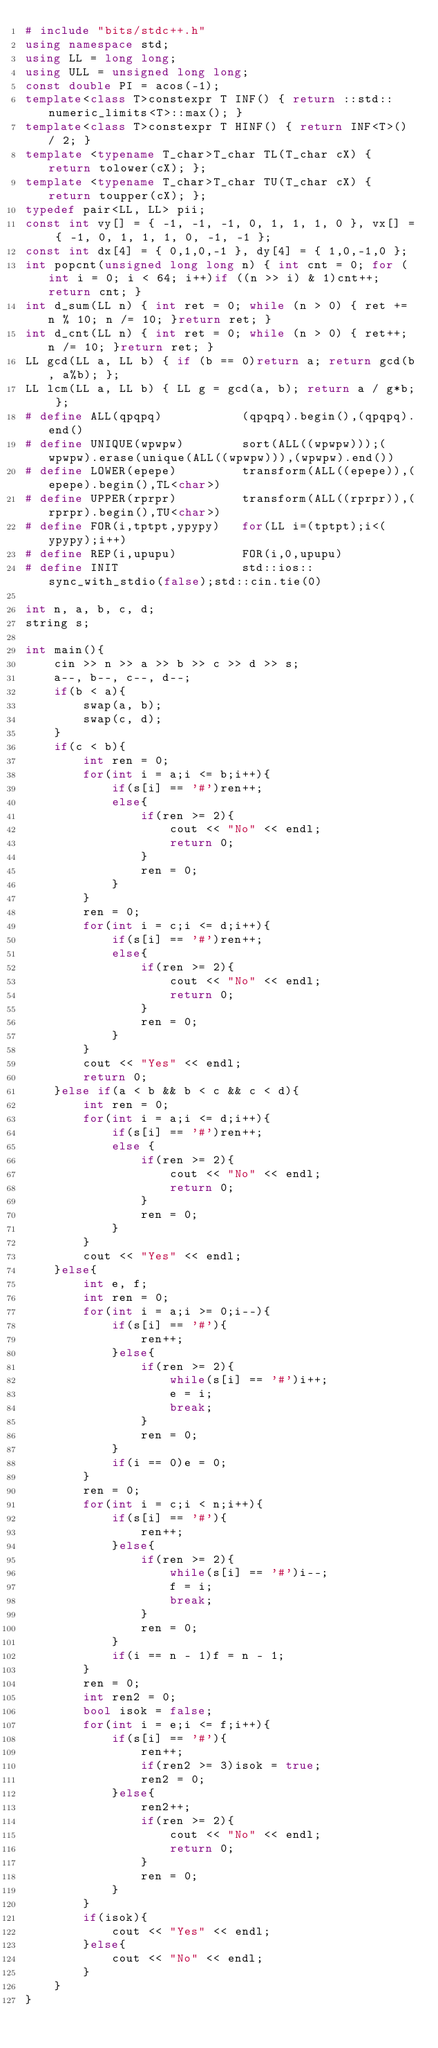<code> <loc_0><loc_0><loc_500><loc_500><_C++_># include "bits/stdc++.h"
using namespace std;
using LL = long long;
using ULL = unsigned long long;
const double PI = acos(-1);
template<class T>constexpr T INF() { return ::std::numeric_limits<T>::max(); }
template<class T>constexpr T HINF() { return INF<T>() / 2; }
template <typename T_char>T_char TL(T_char cX) { return tolower(cX); };
template <typename T_char>T_char TU(T_char cX) { return toupper(cX); };
typedef pair<LL, LL> pii;
const int vy[] = { -1, -1, -1, 0, 1, 1, 1, 0 }, vx[] = { -1, 0, 1, 1, 1, 0, -1, -1 };
const int dx[4] = { 0,1,0,-1 }, dy[4] = { 1,0,-1,0 };
int popcnt(unsigned long long n) { int cnt = 0; for (int i = 0; i < 64; i++)if ((n >> i) & 1)cnt++; return cnt; }
int d_sum(LL n) { int ret = 0; while (n > 0) { ret += n % 10; n /= 10; }return ret; }
int d_cnt(LL n) { int ret = 0; while (n > 0) { ret++; n /= 10; }return ret; }
LL gcd(LL a, LL b) { if (b == 0)return a; return gcd(b, a%b); };
LL lcm(LL a, LL b) { LL g = gcd(a, b); return a / g*b; };
# define ALL(qpqpq)           (qpqpq).begin(),(qpqpq).end()
# define UNIQUE(wpwpw)        sort(ALL((wpwpw)));(wpwpw).erase(unique(ALL((wpwpw))),(wpwpw).end())
# define LOWER(epepe)         transform(ALL((epepe)),(epepe).begin(),TL<char>)
# define UPPER(rprpr)         transform(ALL((rprpr)),(rprpr).begin(),TU<char>)
# define FOR(i,tptpt,ypypy)   for(LL i=(tptpt);i<(ypypy);i++)
# define REP(i,upupu)         FOR(i,0,upupu)
# define INIT                 std::ios::sync_with_stdio(false);std::cin.tie(0)

int n, a, b, c, d;
string s;

int main(){
    cin >> n >> a >> b >> c >> d >> s;
    a--, b--, c--, d--;
    if(b < a){
        swap(a, b);
        swap(c, d);
    }
    if(c < b){
        int ren = 0;
        for(int i = a;i <= b;i++){
            if(s[i] == '#')ren++;
            else{
                if(ren >= 2){
                    cout << "No" << endl;
                    return 0;
                }
                ren = 0;
            }
        }
        ren = 0;
        for(int i = c;i <= d;i++){
            if(s[i] == '#')ren++;
            else{
                if(ren >= 2){
                    cout << "No" << endl;
                    return 0;
                }
                ren = 0;
            }
        }
        cout << "Yes" << endl;
        return 0;
    }else if(a < b && b < c && c < d){
        int ren = 0;
        for(int i = a;i <= d;i++){
            if(s[i] == '#')ren++;
            else {
                if(ren >= 2){
                    cout << "No" << endl;
                    return 0;
                }
                ren = 0;
            }
        }
        cout << "Yes" << endl;
    }else{
        int e, f;
        int ren = 0;
        for(int i = a;i >= 0;i--){
            if(s[i] == '#'){
                ren++;
            }else{
                if(ren >= 2){
                    while(s[i] == '#')i++;
                    e = i;
                    break;
                }
                ren = 0;
            }
            if(i == 0)e = 0;
        }
        ren = 0;
        for(int i = c;i < n;i++){
            if(s[i] == '#'){
                ren++;
            }else{
                if(ren >= 2){
                    while(s[i] == '#')i--;
                    f = i;
                    break;
                }
                ren = 0;
            }
            if(i == n - 1)f = n - 1;
        }
        ren = 0;
        int ren2 = 0;
        bool isok = false;
        for(int i = e;i <= f;i++){
            if(s[i] == '#'){
                ren++;
                if(ren2 >= 3)isok = true;
                ren2 = 0;
            }else{
                ren2++;
                if(ren >= 2){
                    cout << "No" << endl;
                    return 0;
                }
                ren = 0;
            }
        }
        if(isok){
            cout << "Yes" << endl;
        }else{
            cout << "No" << endl;
        }
    }
}</code> 